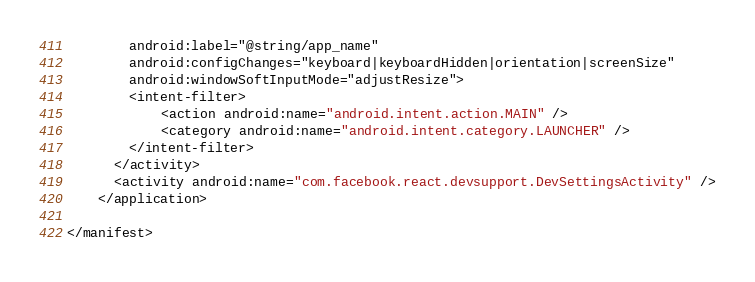Convert code to text. <code><loc_0><loc_0><loc_500><loc_500><_XML_>        android:label="@string/app_name"
        android:configChanges="keyboard|keyboardHidden|orientation|screenSize"
        android:windowSoftInputMode="adjustResize">
        <intent-filter>
            <action android:name="android.intent.action.MAIN" />
            <category android:name="android.intent.category.LAUNCHER" />
        </intent-filter>
      </activity>
      <activity android:name="com.facebook.react.devsupport.DevSettingsActivity" />
    </application>

</manifest>
</code> 